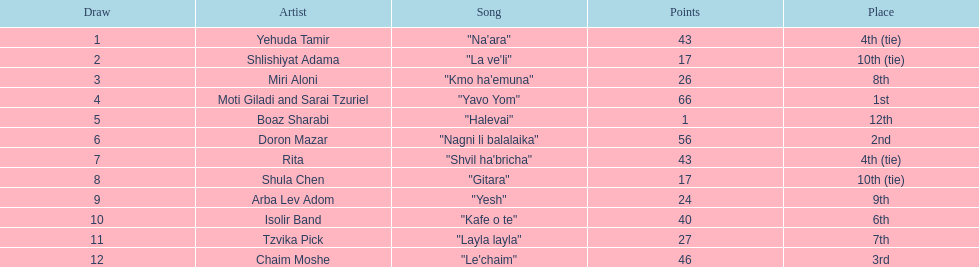In which position did the competitor with a single point finish? 12th. What is the name of the previously mentioned artist? Boaz Sharabi. 